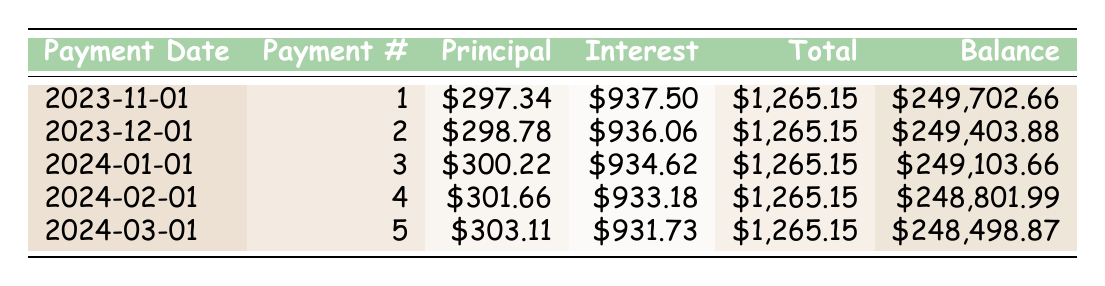What is the total monthly payment for the mortgage? The total monthly payment is a fixed amount listed in the loan details. It states the total payment is 1265.15.
Answer: 1265.15 How much of the first payment goes toward the principal? The first payment's principal payment, as per the table, is indicated as 297.34.
Answer: 297.34 What is the remaining balance after the second payment? The second payment's remaining balance can be found directly in the payment schedule for payment number 2, which shows a remaining balance of 249403.88.
Answer: 249403.88 Is the principal amount in the first payment greater than the principal amount in the fourth payment? The principal payment for the first payment is 297.34, while for the fourth payment, it is 301.66. Since 297.34 is less than 301.66, the answer is no.
Answer: No What is the sum of principal payments from the first five payments? To find the sum, add up the principal payments: 297.34 + 298.78 + 300.22 + 301.66 + 303.11 = 1501.11. The result is calculated by summing these five values.
Answer: 1501.11 What is the average interest payment for the first five months? First, we identify the interest payments for the first five payments: 937.50, 936.06, 934.62, 933.18, 931.73. The total is 937.50 + 936.06 + 934.62 + 933.18 + 931.73 = 4672.09. Dividing this total by 5 gives the average interest payment: 4672.09 / 5 = 934.418.
Answer: 934.42 How much interest is paid in the second payment compared to the interest in the fifth payment? The interest payment in the second payment is 936.06 and in the fifth payment, it is 931.73. To compare, we find that the second payment has slightly more interest, since 936.06 is greater than 931.73.
Answer: Yes What is the change in principal payment from the first to the fifth month? The first payment's principal is 297.34 and the fifth payment's principal is 303.11. The change is calculated as 303.11 - 297.34 = 5.77, indicating an increase in the principal payment over the months.
Answer: 5.77 What is the total remaining balance after the fifth payment? The remaining balance after the fifth payment is directly provided in the payment schedule for payment number 5, which states the remaining balance is 248498.87.
Answer: 248498.87 